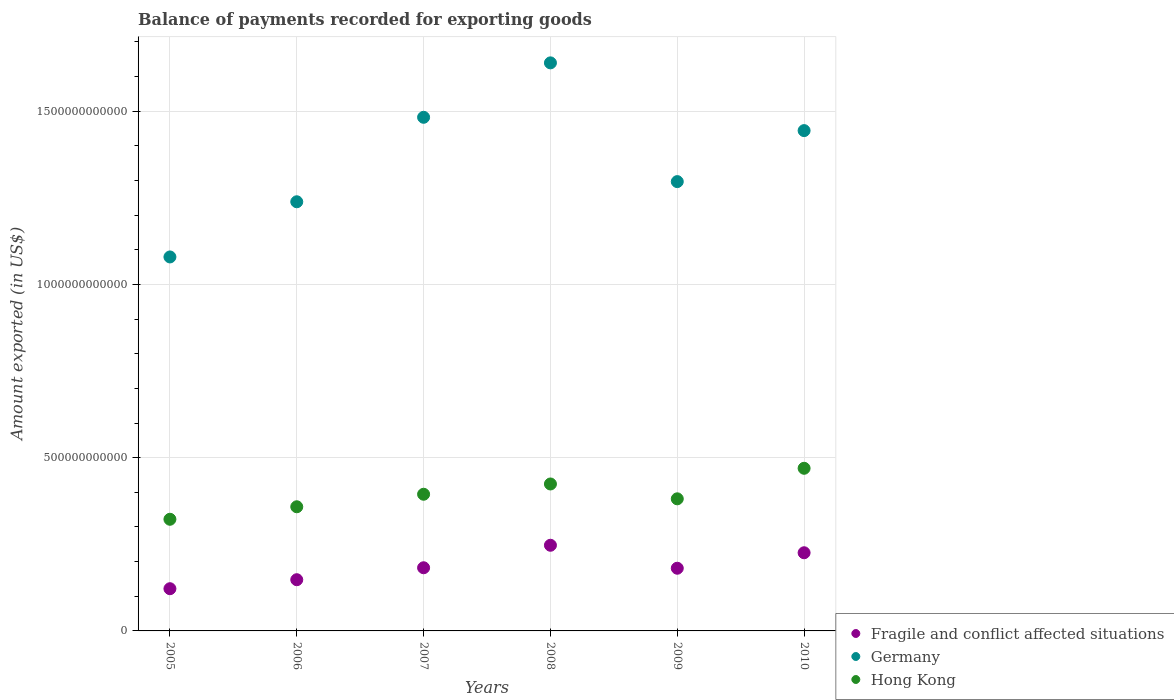Is the number of dotlines equal to the number of legend labels?
Ensure brevity in your answer.  Yes. What is the amount exported in Hong Kong in 2010?
Keep it short and to the point. 4.69e+11. Across all years, what is the maximum amount exported in Hong Kong?
Your answer should be compact. 4.69e+11. Across all years, what is the minimum amount exported in Germany?
Your response must be concise. 1.08e+12. In which year was the amount exported in Germany maximum?
Offer a very short reply. 2008. In which year was the amount exported in Germany minimum?
Provide a short and direct response. 2005. What is the total amount exported in Germany in the graph?
Offer a terse response. 8.18e+12. What is the difference between the amount exported in Hong Kong in 2005 and that in 2008?
Your answer should be very brief. -1.02e+11. What is the difference between the amount exported in Germany in 2005 and the amount exported in Fragile and conflict affected situations in 2009?
Keep it short and to the point. 8.99e+11. What is the average amount exported in Germany per year?
Ensure brevity in your answer.  1.36e+12. In the year 2009, what is the difference between the amount exported in Fragile and conflict affected situations and amount exported in Germany?
Provide a short and direct response. -1.12e+12. In how many years, is the amount exported in Fragile and conflict affected situations greater than 1200000000000 US$?
Offer a very short reply. 0. What is the ratio of the amount exported in Germany in 2005 to that in 2007?
Offer a terse response. 0.73. Is the amount exported in Fragile and conflict affected situations in 2007 less than that in 2010?
Your response must be concise. Yes. Is the difference between the amount exported in Fragile and conflict affected situations in 2006 and 2010 greater than the difference between the amount exported in Germany in 2006 and 2010?
Your answer should be compact. Yes. What is the difference between the highest and the second highest amount exported in Hong Kong?
Your answer should be very brief. 4.53e+1. What is the difference between the highest and the lowest amount exported in Germany?
Make the answer very short. 5.60e+11. Is the sum of the amount exported in Hong Kong in 2005 and 2007 greater than the maximum amount exported in Germany across all years?
Your response must be concise. No. Is the amount exported in Fragile and conflict affected situations strictly greater than the amount exported in Hong Kong over the years?
Your answer should be very brief. No. How many dotlines are there?
Ensure brevity in your answer.  3. How many years are there in the graph?
Ensure brevity in your answer.  6. What is the difference between two consecutive major ticks on the Y-axis?
Your answer should be very brief. 5.00e+11. Does the graph contain any zero values?
Your answer should be compact. No. Does the graph contain grids?
Provide a short and direct response. Yes. Where does the legend appear in the graph?
Ensure brevity in your answer.  Bottom right. What is the title of the graph?
Give a very brief answer. Balance of payments recorded for exporting goods. What is the label or title of the X-axis?
Make the answer very short. Years. What is the label or title of the Y-axis?
Offer a terse response. Amount exported (in US$). What is the Amount exported (in US$) of Fragile and conflict affected situations in 2005?
Provide a short and direct response. 1.22e+11. What is the Amount exported (in US$) of Germany in 2005?
Ensure brevity in your answer.  1.08e+12. What is the Amount exported (in US$) of Hong Kong in 2005?
Offer a very short reply. 3.22e+11. What is the Amount exported (in US$) in Fragile and conflict affected situations in 2006?
Offer a very short reply. 1.48e+11. What is the Amount exported (in US$) of Germany in 2006?
Keep it short and to the point. 1.24e+12. What is the Amount exported (in US$) in Hong Kong in 2006?
Your answer should be compact. 3.58e+11. What is the Amount exported (in US$) of Fragile and conflict affected situations in 2007?
Make the answer very short. 1.82e+11. What is the Amount exported (in US$) of Germany in 2007?
Keep it short and to the point. 1.48e+12. What is the Amount exported (in US$) in Hong Kong in 2007?
Offer a very short reply. 3.94e+11. What is the Amount exported (in US$) in Fragile and conflict affected situations in 2008?
Keep it short and to the point. 2.47e+11. What is the Amount exported (in US$) in Germany in 2008?
Provide a succinct answer. 1.64e+12. What is the Amount exported (in US$) in Hong Kong in 2008?
Keep it short and to the point. 4.24e+11. What is the Amount exported (in US$) in Fragile and conflict affected situations in 2009?
Provide a succinct answer. 1.81e+11. What is the Amount exported (in US$) of Germany in 2009?
Keep it short and to the point. 1.30e+12. What is the Amount exported (in US$) of Hong Kong in 2009?
Give a very brief answer. 3.81e+11. What is the Amount exported (in US$) in Fragile and conflict affected situations in 2010?
Offer a terse response. 2.26e+11. What is the Amount exported (in US$) of Germany in 2010?
Ensure brevity in your answer.  1.44e+12. What is the Amount exported (in US$) in Hong Kong in 2010?
Your response must be concise. 4.69e+11. Across all years, what is the maximum Amount exported (in US$) in Fragile and conflict affected situations?
Provide a short and direct response. 2.47e+11. Across all years, what is the maximum Amount exported (in US$) in Germany?
Keep it short and to the point. 1.64e+12. Across all years, what is the maximum Amount exported (in US$) of Hong Kong?
Your response must be concise. 4.69e+11. Across all years, what is the minimum Amount exported (in US$) of Fragile and conflict affected situations?
Ensure brevity in your answer.  1.22e+11. Across all years, what is the minimum Amount exported (in US$) in Germany?
Ensure brevity in your answer.  1.08e+12. Across all years, what is the minimum Amount exported (in US$) in Hong Kong?
Your answer should be compact. 3.22e+11. What is the total Amount exported (in US$) of Fragile and conflict affected situations in the graph?
Offer a very short reply. 1.11e+12. What is the total Amount exported (in US$) of Germany in the graph?
Your response must be concise. 8.18e+12. What is the total Amount exported (in US$) in Hong Kong in the graph?
Provide a short and direct response. 2.35e+12. What is the difference between the Amount exported (in US$) in Fragile and conflict affected situations in 2005 and that in 2006?
Your response must be concise. -2.60e+1. What is the difference between the Amount exported (in US$) of Germany in 2005 and that in 2006?
Give a very brief answer. -1.59e+11. What is the difference between the Amount exported (in US$) of Hong Kong in 2005 and that in 2006?
Your response must be concise. -3.61e+1. What is the difference between the Amount exported (in US$) of Fragile and conflict affected situations in 2005 and that in 2007?
Your response must be concise. -6.04e+1. What is the difference between the Amount exported (in US$) in Germany in 2005 and that in 2007?
Make the answer very short. -4.03e+11. What is the difference between the Amount exported (in US$) of Hong Kong in 2005 and that in 2007?
Provide a short and direct response. -7.22e+1. What is the difference between the Amount exported (in US$) in Fragile and conflict affected situations in 2005 and that in 2008?
Keep it short and to the point. -1.25e+11. What is the difference between the Amount exported (in US$) of Germany in 2005 and that in 2008?
Ensure brevity in your answer.  -5.60e+11. What is the difference between the Amount exported (in US$) of Hong Kong in 2005 and that in 2008?
Your answer should be compact. -1.02e+11. What is the difference between the Amount exported (in US$) of Fragile and conflict affected situations in 2005 and that in 2009?
Provide a succinct answer. -5.91e+1. What is the difference between the Amount exported (in US$) of Germany in 2005 and that in 2009?
Your answer should be compact. -2.17e+11. What is the difference between the Amount exported (in US$) in Hong Kong in 2005 and that in 2009?
Your answer should be very brief. -5.90e+1. What is the difference between the Amount exported (in US$) of Fragile and conflict affected situations in 2005 and that in 2010?
Make the answer very short. -1.04e+11. What is the difference between the Amount exported (in US$) of Germany in 2005 and that in 2010?
Keep it short and to the point. -3.65e+11. What is the difference between the Amount exported (in US$) of Hong Kong in 2005 and that in 2010?
Your response must be concise. -1.47e+11. What is the difference between the Amount exported (in US$) in Fragile and conflict affected situations in 2006 and that in 2007?
Keep it short and to the point. -3.45e+1. What is the difference between the Amount exported (in US$) of Germany in 2006 and that in 2007?
Your response must be concise. -2.44e+11. What is the difference between the Amount exported (in US$) in Hong Kong in 2006 and that in 2007?
Offer a very short reply. -3.61e+1. What is the difference between the Amount exported (in US$) of Fragile and conflict affected situations in 2006 and that in 2008?
Offer a terse response. -9.94e+1. What is the difference between the Amount exported (in US$) of Germany in 2006 and that in 2008?
Offer a very short reply. -4.01e+11. What is the difference between the Amount exported (in US$) of Hong Kong in 2006 and that in 2008?
Your answer should be compact. -6.58e+1. What is the difference between the Amount exported (in US$) of Fragile and conflict affected situations in 2006 and that in 2009?
Offer a very short reply. -3.31e+1. What is the difference between the Amount exported (in US$) of Germany in 2006 and that in 2009?
Your response must be concise. -5.82e+1. What is the difference between the Amount exported (in US$) of Hong Kong in 2006 and that in 2009?
Give a very brief answer. -2.29e+1. What is the difference between the Amount exported (in US$) in Fragile and conflict affected situations in 2006 and that in 2010?
Your response must be concise. -7.78e+1. What is the difference between the Amount exported (in US$) of Germany in 2006 and that in 2010?
Provide a short and direct response. -2.05e+11. What is the difference between the Amount exported (in US$) in Hong Kong in 2006 and that in 2010?
Provide a short and direct response. -1.11e+11. What is the difference between the Amount exported (in US$) in Fragile and conflict affected situations in 2007 and that in 2008?
Your answer should be compact. -6.50e+1. What is the difference between the Amount exported (in US$) of Germany in 2007 and that in 2008?
Make the answer very short. -1.57e+11. What is the difference between the Amount exported (in US$) of Hong Kong in 2007 and that in 2008?
Give a very brief answer. -2.96e+1. What is the difference between the Amount exported (in US$) in Fragile and conflict affected situations in 2007 and that in 2009?
Provide a succinct answer. 1.36e+09. What is the difference between the Amount exported (in US$) of Germany in 2007 and that in 2009?
Your answer should be compact. 1.86e+11. What is the difference between the Amount exported (in US$) of Hong Kong in 2007 and that in 2009?
Provide a short and direct response. 1.32e+1. What is the difference between the Amount exported (in US$) in Fragile and conflict affected situations in 2007 and that in 2010?
Your answer should be compact. -4.33e+1. What is the difference between the Amount exported (in US$) of Germany in 2007 and that in 2010?
Provide a short and direct response. 3.84e+1. What is the difference between the Amount exported (in US$) of Hong Kong in 2007 and that in 2010?
Ensure brevity in your answer.  -7.50e+1. What is the difference between the Amount exported (in US$) in Fragile and conflict affected situations in 2008 and that in 2009?
Keep it short and to the point. 6.63e+1. What is the difference between the Amount exported (in US$) of Germany in 2008 and that in 2009?
Keep it short and to the point. 3.43e+11. What is the difference between the Amount exported (in US$) in Hong Kong in 2008 and that in 2009?
Provide a succinct answer. 4.28e+1. What is the difference between the Amount exported (in US$) of Fragile and conflict affected situations in 2008 and that in 2010?
Offer a terse response. 2.17e+1. What is the difference between the Amount exported (in US$) in Germany in 2008 and that in 2010?
Keep it short and to the point. 1.96e+11. What is the difference between the Amount exported (in US$) of Hong Kong in 2008 and that in 2010?
Your answer should be compact. -4.53e+1. What is the difference between the Amount exported (in US$) of Fragile and conflict affected situations in 2009 and that in 2010?
Provide a short and direct response. -4.47e+1. What is the difference between the Amount exported (in US$) of Germany in 2009 and that in 2010?
Keep it short and to the point. -1.47e+11. What is the difference between the Amount exported (in US$) of Hong Kong in 2009 and that in 2010?
Your answer should be very brief. -8.81e+1. What is the difference between the Amount exported (in US$) of Fragile and conflict affected situations in 2005 and the Amount exported (in US$) of Germany in 2006?
Give a very brief answer. -1.12e+12. What is the difference between the Amount exported (in US$) in Fragile and conflict affected situations in 2005 and the Amount exported (in US$) in Hong Kong in 2006?
Your response must be concise. -2.37e+11. What is the difference between the Amount exported (in US$) in Germany in 2005 and the Amount exported (in US$) in Hong Kong in 2006?
Keep it short and to the point. 7.21e+11. What is the difference between the Amount exported (in US$) in Fragile and conflict affected situations in 2005 and the Amount exported (in US$) in Germany in 2007?
Your response must be concise. -1.36e+12. What is the difference between the Amount exported (in US$) of Fragile and conflict affected situations in 2005 and the Amount exported (in US$) of Hong Kong in 2007?
Offer a terse response. -2.73e+11. What is the difference between the Amount exported (in US$) of Germany in 2005 and the Amount exported (in US$) of Hong Kong in 2007?
Make the answer very short. 6.85e+11. What is the difference between the Amount exported (in US$) in Fragile and conflict affected situations in 2005 and the Amount exported (in US$) in Germany in 2008?
Ensure brevity in your answer.  -1.52e+12. What is the difference between the Amount exported (in US$) in Fragile and conflict affected situations in 2005 and the Amount exported (in US$) in Hong Kong in 2008?
Ensure brevity in your answer.  -3.02e+11. What is the difference between the Amount exported (in US$) of Germany in 2005 and the Amount exported (in US$) of Hong Kong in 2008?
Provide a short and direct response. 6.55e+11. What is the difference between the Amount exported (in US$) of Fragile and conflict affected situations in 2005 and the Amount exported (in US$) of Germany in 2009?
Offer a terse response. -1.18e+12. What is the difference between the Amount exported (in US$) of Fragile and conflict affected situations in 2005 and the Amount exported (in US$) of Hong Kong in 2009?
Ensure brevity in your answer.  -2.59e+11. What is the difference between the Amount exported (in US$) of Germany in 2005 and the Amount exported (in US$) of Hong Kong in 2009?
Ensure brevity in your answer.  6.98e+11. What is the difference between the Amount exported (in US$) of Fragile and conflict affected situations in 2005 and the Amount exported (in US$) of Germany in 2010?
Ensure brevity in your answer.  -1.32e+12. What is the difference between the Amount exported (in US$) in Fragile and conflict affected situations in 2005 and the Amount exported (in US$) in Hong Kong in 2010?
Ensure brevity in your answer.  -3.48e+11. What is the difference between the Amount exported (in US$) of Germany in 2005 and the Amount exported (in US$) of Hong Kong in 2010?
Offer a very short reply. 6.10e+11. What is the difference between the Amount exported (in US$) in Fragile and conflict affected situations in 2006 and the Amount exported (in US$) in Germany in 2007?
Ensure brevity in your answer.  -1.33e+12. What is the difference between the Amount exported (in US$) in Fragile and conflict affected situations in 2006 and the Amount exported (in US$) in Hong Kong in 2007?
Provide a succinct answer. -2.47e+11. What is the difference between the Amount exported (in US$) in Germany in 2006 and the Amount exported (in US$) in Hong Kong in 2007?
Ensure brevity in your answer.  8.44e+11. What is the difference between the Amount exported (in US$) in Fragile and conflict affected situations in 2006 and the Amount exported (in US$) in Germany in 2008?
Provide a short and direct response. -1.49e+12. What is the difference between the Amount exported (in US$) in Fragile and conflict affected situations in 2006 and the Amount exported (in US$) in Hong Kong in 2008?
Make the answer very short. -2.76e+11. What is the difference between the Amount exported (in US$) of Germany in 2006 and the Amount exported (in US$) of Hong Kong in 2008?
Ensure brevity in your answer.  8.15e+11. What is the difference between the Amount exported (in US$) of Fragile and conflict affected situations in 2006 and the Amount exported (in US$) of Germany in 2009?
Provide a short and direct response. -1.15e+12. What is the difference between the Amount exported (in US$) in Fragile and conflict affected situations in 2006 and the Amount exported (in US$) in Hong Kong in 2009?
Your answer should be compact. -2.33e+11. What is the difference between the Amount exported (in US$) of Germany in 2006 and the Amount exported (in US$) of Hong Kong in 2009?
Your answer should be compact. 8.57e+11. What is the difference between the Amount exported (in US$) in Fragile and conflict affected situations in 2006 and the Amount exported (in US$) in Germany in 2010?
Provide a succinct answer. -1.30e+12. What is the difference between the Amount exported (in US$) in Fragile and conflict affected situations in 2006 and the Amount exported (in US$) in Hong Kong in 2010?
Offer a very short reply. -3.22e+11. What is the difference between the Amount exported (in US$) in Germany in 2006 and the Amount exported (in US$) in Hong Kong in 2010?
Your response must be concise. 7.69e+11. What is the difference between the Amount exported (in US$) of Fragile and conflict affected situations in 2007 and the Amount exported (in US$) of Germany in 2008?
Your response must be concise. -1.46e+12. What is the difference between the Amount exported (in US$) in Fragile and conflict affected situations in 2007 and the Amount exported (in US$) in Hong Kong in 2008?
Make the answer very short. -2.42e+11. What is the difference between the Amount exported (in US$) of Germany in 2007 and the Amount exported (in US$) of Hong Kong in 2008?
Your answer should be compact. 1.06e+12. What is the difference between the Amount exported (in US$) in Fragile and conflict affected situations in 2007 and the Amount exported (in US$) in Germany in 2009?
Give a very brief answer. -1.11e+12. What is the difference between the Amount exported (in US$) of Fragile and conflict affected situations in 2007 and the Amount exported (in US$) of Hong Kong in 2009?
Offer a terse response. -1.99e+11. What is the difference between the Amount exported (in US$) of Germany in 2007 and the Amount exported (in US$) of Hong Kong in 2009?
Give a very brief answer. 1.10e+12. What is the difference between the Amount exported (in US$) of Fragile and conflict affected situations in 2007 and the Amount exported (in US$) of Germany in 2010?
Your answer should be very brief. -1.26e+12. What is the difference between the Amount exported (in US$) in Fragile and conflict affected situations in 2007 and the Amount exported (in US$) in Hong Kong in 2010?
Your answer should be very brief. -2.87e+11. What is the difference between the Amount exported (in US$) of Germany in 2007 and the Amount exported (in US$) of Hong Kong in 2010?
Offer a terse response. 1.01e+12. What is the difference between the Amount exported (in US$) in Fragile and conflict affected situations in 2008 and the Amount exported (in US$) in Germany in 2009?
Make the answer very short. -1.05e+12. What is the difference between the Amount exported (in US$) in Fragile and conflict affected situations in 2008 and the Amount exported (in US$) in Hong Kong in 2009?
Your answer should be compact. -1.34e+11. What is the difference between the Amount exported (in US$) of Germany in 2008 and the Amount exported (in US$) of Hong Kong in 2009?
Keep it short and to the point. 1.26e+12. What is the difference between the Amount exported (in US$) in Fragile and conflict affected situations in 2008 and the Amount exported (in US$) in Germany in 2010?
Your response must be concise. -1.20e+12. What is the difference between the Amount exported (in US$) of Fragile and conflict affected situations in 2008 and the Amount exported (in US$) of Hong Kong in 2010?
Offer a terse response. -2.22e+11. What is the difference between the Amount exported (in US$) in Germany in 2008 and the Amount exported (in US$) in Hong Kong in 2010?
Make the answer very short. 1.17e+12. What is the difference between the Amount exported (in US$) in Fragile and conflict affected situations in 2009 and the Amount exported (in US$) in Germany in 2010?
Ensure brevity in your answer.  -1.26e+12. What is the difference between the Amount exported (in US$) in Fragile and conflict affected situations in 2009 and the Amount exported (in US$) in Hong Kong in 2010?
Provide a short and direct response. -2.89e+11. What is the difference between the Amount exported (in US$) of Germany in 2009 and the Amount exported (in US$) of Hong Kong in 2010?
Your answer should be compact. 8.27e+11. What is the average Amount exported (in US$) of Fragile and conflict affected situations per year?
Your response must be concise. 1.84e+11. What is the average Amount exported (in US$) in Germany per year?
Offer a very short reply. 1.36e+12. What is the average Amount exported (in US$) in Hong Kong per year?
Your answer should be compact. 3.92e+11. In the year 2005, what is the difference between the Amount exported (in US$) in Fragile and conflict affected situations and Amount exported (in US$) in Germany?
Your response must be concise. -9.58e+11. In the year 2005, what is the difference between the Amount exported (in US$) in Fragile and conflict affected situations and Amount exported (in US$) in Hong Kong?
Give a very brief answer. -2.00e+11. In the year 2005, what is the difference between the Amount exported (in US$) in Germany and Amount exported (in US$) in Hong Kong?
Keep it short and to the point. 7.57e+11. In the year 2006, what is the difference between the Amount exported (in US$) of Fragile and conflict affected situations and Amount exported (in US$) of Germany?
Your answer should be compact. -1.09e+12. In the year 2006, what is the difference between the Amount exported (in US$) of Fragile and conflict affected situations and Amount exported (in US$) of Hong Kong?
Make the answer very short. -2.11e+11. In the year 2006, what is the difference between the Amount exported (in US$) of Germany and Amount exported (in US$) of Hong Kong?
Provide a succinct answer. 8.80e+11. In the year 2007, what is the difference between the Amount exported (in US$) of Fragile and conflict affected situations and Amount exported (in US$) of Germany?
Your answer should be very brief. -1.30e+12. In the year 2007, what is the difference between the Amount exported (in US$) in Fragile and conflict affected situations and Amount exported (in US$) in Hong Kong?
Make the answer very short. -2.12e+11. In the year 2007, what is the difference between the Amount exported (in US$) in Germany and Amount exported (in US$) in Hong Kong?
Your answer should be very brief. 1.09e+12. In the year 2008, what is the difference between the Amount exported (in US$) of Fragile and conflict affected situations and Amount exported (in US$) of Germany?
Your answer should be very brief. -1.39e+12. In the year 2008, what is the difference between the Amount exported (in US$) of Fragile and conflict affected situations and Amount exported (in US$) of Hong Kong?
Your answer should be compact. -1.77e+11. In the year 2008, what is the difference between the Amount exported (in US$) of Germany and Amount exported (in US$) of Hong Kong?
Provide a succinct answer. 1.22e+12. In the year 2009, what is the difference between the Amount exported (in US$) of Fragile and conflict affected situations and Amount exported (in US$) of Germany?
Provide a short and direct response. -1.12e+12. In the year 2009, what is the difference between the Amount exported (in US$) in Fragile and conflict affected situations and Amount exported (in US$) in Hong Kong?
Give a very brief answer. -2.00e+11. In the year 2009, what is the difference between the Amount exported (in US$) of Germany and Amount exported (in US$) of Hong Kong?
Give a very brief answer. 9.16e+11. In the year 2010, what is the difference between the Amount exported (in US$) in Fragile and conflict affected situations and Amount exported (in US$) in Germany?
Provide a short and direct response. -1.22e+12. In the year 2010, what is the difference between the Amount exported (in US$) in Fragile and conflict affected situations and Amount exported (in US$) in Hong Kong?
Make the answer very short. -2.44e+11. In the year 2010, what is the difference between the Amount exported (in US$) of Germany and Amount exported (in US$) of Hong Kong?
Your answer should be very brief. 9.75e+11. What is the ratio of the Amount exported (in US$) in Fragile and conflict affected situations in 2005 to that in 2006?
Offer a very short reply. 0.82. What is the ratio of the Amount exported (in US$) of Germany in 2005 to that in 2006?
Keep it short and to the point. 0.87. What is the ratio of the Amount exported (in US$) of Hong Kong in 2005 to that in 2006?
Your response must be concise. 0.9. What is the ratio of the Amount exported (in US$) in Fragile and conflict affected situations in 2005 to that in 2007?
Offer a very short reply. 0.67. What is the ratio of the Amount exported (in US$) of Germany in 2005 to that in 2007?
Give a very brief answer. 0.73. What is the ratio of the Amount exported (in US$) in Hong Kong in 2005 to that in 2007?
Your answer should be compact. 0.82. What is the ratio of the Amount exported (in US$) of Fragile and conflict affected situations in 2005 to that in 2008?
Provide a short and direct response. 0.49. What is the ratio of the Amount exported (in US$) of Germany in 2005 to that in 2008?
Make the answer very short. 0.66. What is the ratio of the Amount exported (in US$) of Hong Kong in 2005 to that in 2008?
Give a very brief answer. 0.76. What is the ratio of the Amount exported (in US$) in Fragile and conflict affected situations in 2005 to that in 2009?
Offer a very short reply. 0.67. What is the ratio of the Amount exported (in US$) of Germany in 2005 to that in 2009?
Give a very brief answer. 0.83. What is the ratio of the Amount exported (in US$) of Hong Kong in 2005 to that in 2009?
Your response must be concise. 0.85. What is the ratio of the Amount exported (in US$) of Fragile and conflict affected situations in 2005 to that in 2010?
Provide a succinct answer. 0.54. What is the ratio of the Amount exported (in US$) in Germany in 2005 to that in 2010?
Give a very brief answer. 0.75. What is the ratio of the Amount exported (in US$) in Hong Kong in 2005 to that in 2010?
Provide a short and direct response. 0.69. What is the ratio of the Amount exported (in US$) in Fragile and conflict affected situations in 2006 to that in 2007?
Keep it short and to the point. 0.81. What is the ratio of the Amount exported (in US$) in Germany in 2006 to that in 2007?
Offer a terse response. 0.84. What is the ratio of the Amount exported (in US$) of Hong Kong in 2006 to that in 2007?
Offer a terse response. 0.91. What is the ratio of the Amount exported (in US$) in Fragile and conflict affected situations in 2006 to that in 2008?
Your response must be concise. 0.6. What is the ratio of the Amount exported (in US$) of Germany in 2006 to that in 2008?
Your response must be concise. 0.76. What is the ratio of the Amount exported (in US$) in Hong Kong in 2006 to that in 2008?
Provide a short and direct response. 0.84. What is the ratio of the Amount exported (in US$) in Fragile and conflict affected situations in 2006 to that in 2009?
Your response must be concise. 0.82. What is the ratio of the Amount exported (in US$) in Germany in 2006 to that in 2009?
Offer a very short reply. 0.96. What is the ratio of the Amount exported (in US$) of Hong Kong in 2006 to that in 2009?
Your response must be concise. 0.94. What is the ratio of the Amount exported (in US$) in Fragile and conflict affected situations in 2006 to that in 2010?
Your answer should be very brief. 0.66. What is the ratio of the Amount exported (in US$) of Germany in 2006 to that in 2010?
Provide a short and direct response. 0.86. What is the ratio of the Amount exported (in US$) of Hong Kong in 2006 to that in 2010?
Offer a terse response. 0.76. What is the ratio of the Amount exported (in US$) in Fragile and conflict affected situations in 2007 to that in 2008?
Provide a succinct answer. 0.74. What is the ratio of the Amount exported (in US$) of Germany in 2007 to that in 2008?
Give a very brief answer. 0.9. What is the ratio of the Amount exported (in US$) of Hong Kong in 2007 to that in 2008?
Your answer should be compact. 0.93. What is the ratio of the Amount exported (in US$) of Fragile and conflict affected situations in 2007 to that in 2009?
Offer a very short reply. 1.01. What is the ratio of the Amount exported (in US$) of Germany in 2007 to that in 2009?
Give a very brief answer. 1.14. What is the ratio of the Amount exported (in US$) of Hong Kong in 2007 to that in 2009?
Your response must be concise. 1.03. What is the ratio of the Amount exported (in US$) of Fragile and conflict affected situations in 2007 to that in 2010?
Offer a very short reply. 0.81. What is the ratio of the Amount exported (in US$) of Germany in 2007 to that in 2010?
Keep it short and to the point. 1.03. What is the ratio of the Amount exported (in US$) in Hong Kong in 2007 to that in 2010?
Give a very brief answer. 0.84. What is the ratio of the Amount exported (in US$) of Fragile and conflict affected situations in 2008 to that in 2009?
Ensure brevity in your answer.  1.37. What is the ratio of the Amount exported (in US$) in Germany in 2008 to that in 2009?
Your answer should be compact. 1.26. What is the ratio of the Amount exported (in US$) of Hong Kong in 2008 to that in 2009?
Provide a short and direct response. 1.11. What is the ratio of the Amount exported (in US$) of Fragile and conflict affected situations in 2008 to that in 2010?
Your answer should be very brief. 1.1. What is the ratio of the Amount exported (in US$) of Germany in 2008 to that in 2010?
Offer a terse response. 1.14. What is the ratio of the Amount exported (in US$) of Hong Kong in 2008 to that in 2010?
Provide a short and direct response. 0.9. What is the ratio of the Amount exported (in US$) in Fragile and conflict affected situations in 2009 to that in 2010?
Ensure brevity in your answer.  0.8. What is the ratio of the Amount exported (in US$) in Germany in 2009 to that in 2010?
Your answer should be compact. 0.9. What is the ratio of the Amount exported (in US$) of Hong Kong in 2009 to that in 2010?
Your response must be concise. 0.81. What is the difference between the highest and the second highest Amount exported (in US$) of Fragile and conflict affected situations?
Your answer should be very brief. 2.17e+1. What is the difference between the highest and the second highest Amount exported (in US$) of Germany?
Your answer should be very brief. 1.57e+11. What is the difference between the highest and the second highest Amount exported (in US$) in Hong Kong?
Your response must be concise. 4.53e+1. What is the difference between the highest and the lowest Amount exported (in US$) in Fragile and conflict affected situations?
Your response must be concise. 1.25e+11. What is the difference between the highest and the lowest Amount exported (in US$) in Germany?
Your answer should be compact. 5.60e+11. What is the difference between the highest and the lowest Amount exported (in US$) in Hong Kong?
Offer a terse response. 1.47e+11. 